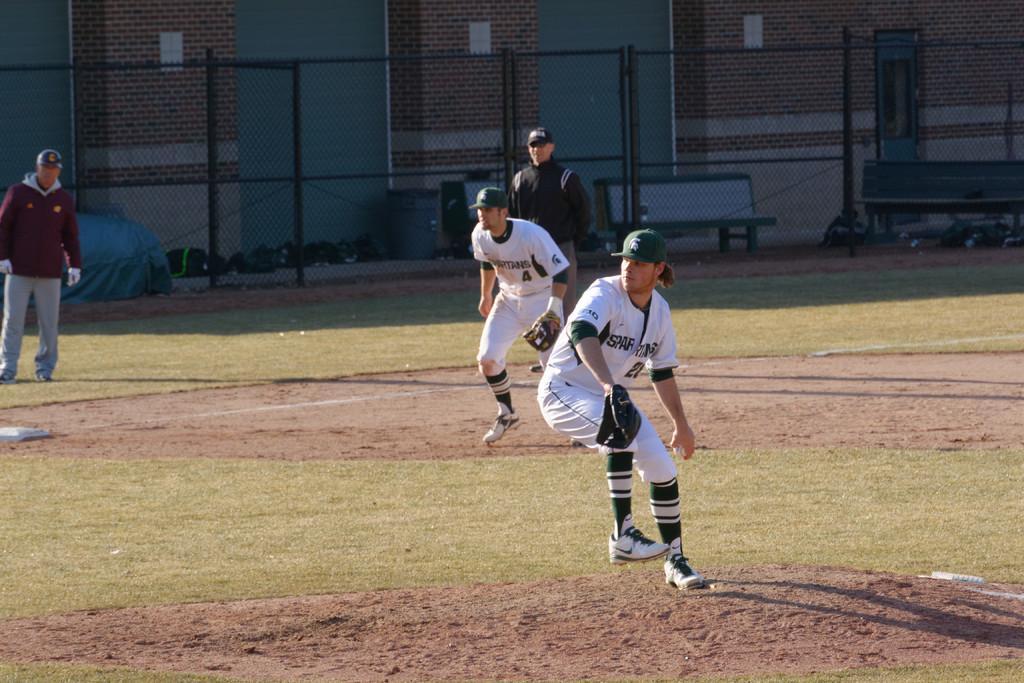How would you summarize this image in a sentence or two? In this image two people are running on the land having some grass. Left side there is a person standing. He is wearing a cap. Middle of the image there is a person wearing a cap. He is standing on the grassland. There is a fence. Behind there is a bench and few objects are on the floor. Background there is a wall. 